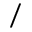Convert formula to latex. <formula><loc_0><loc_0><loc_500><loc_500>/</formula> 